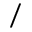Convert formula to latex. <formula><loc_0><loc_0><loc_500><loc_500>/</formula> 